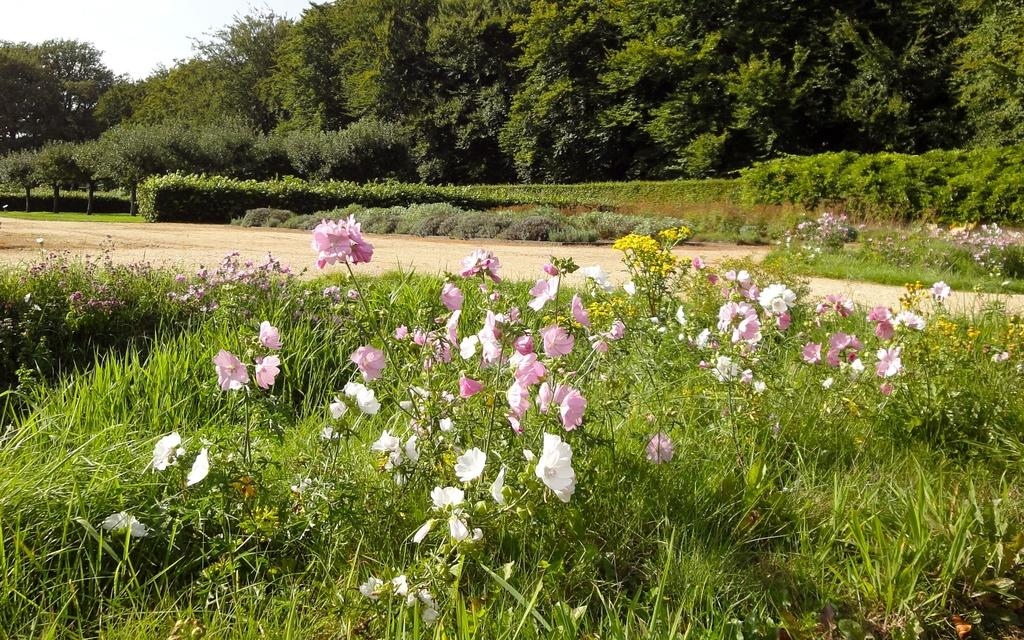What type of vegetation can be seen in the image? There are flowers, plants, and trees in the image. What part of the natural environment is visible in the image? The sky is visible in the image. What type of nut is being cracked open by the fork in the image? There is no nut or fork present in the image; it features flowers, plants, trees, and the sky. 